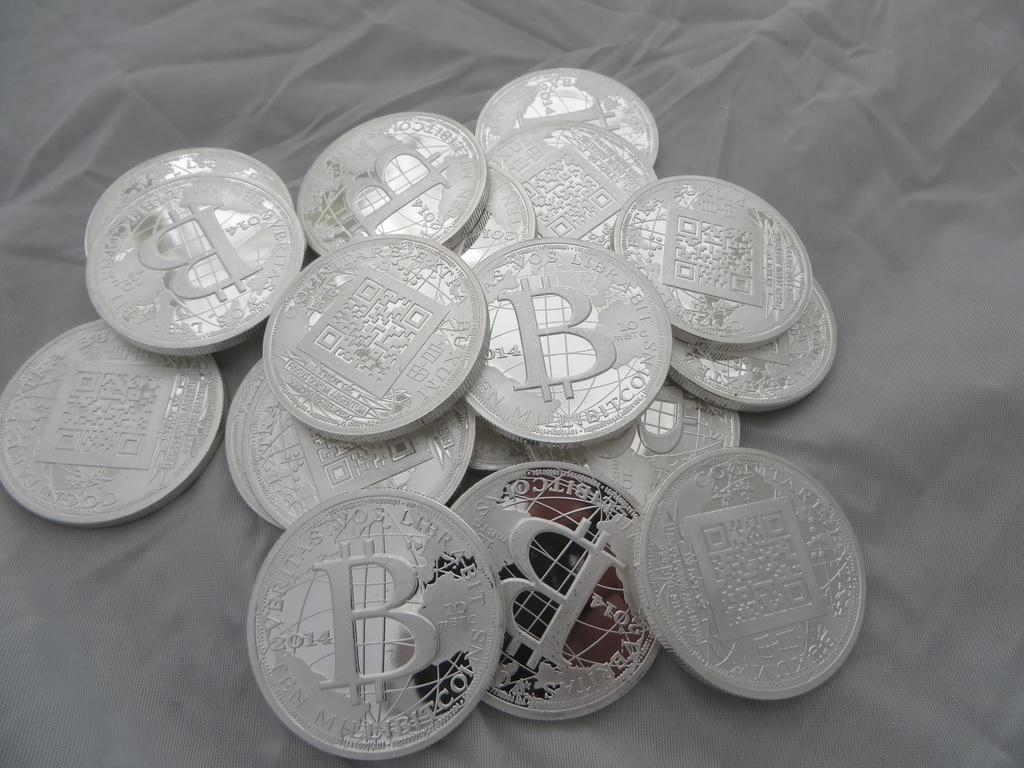<image>
Create a compact narrative representing the image presented. A stack of millibitcoins sit on a gray colored cloth. 